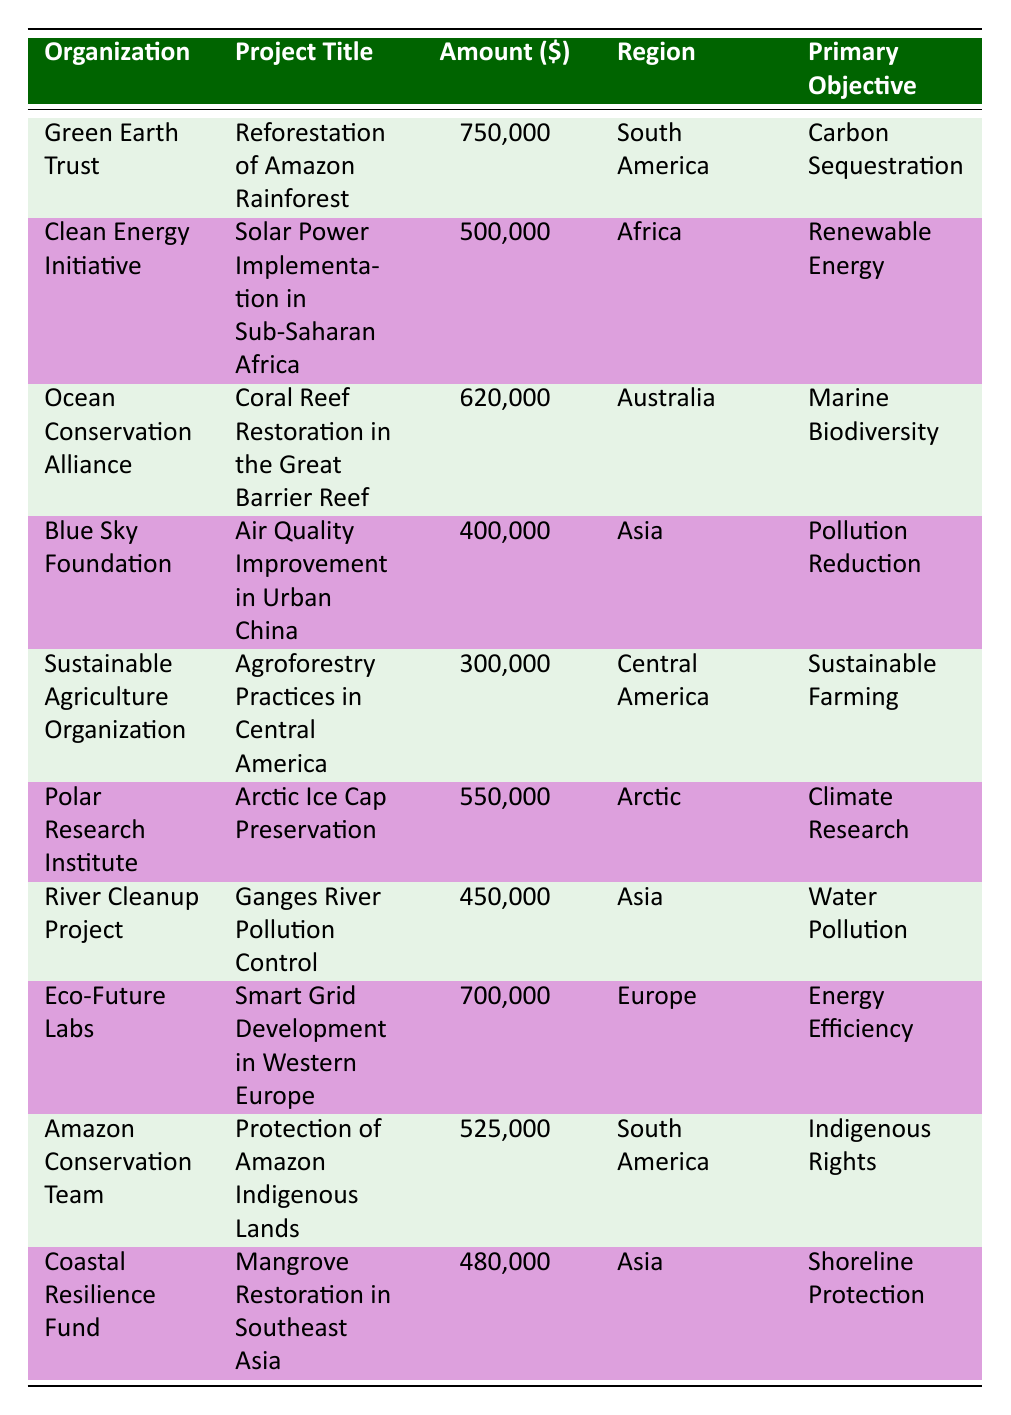How much was allocated to the project "Air Quality Improvement in Urban China"? The table lists "Air Quality Improvement in Urban China" under the organization "Blue Sky Foundation" with an allocated amount of 400,000.
Answer: 400000 What is the primary objective of the "Solar Power Implementation in Sub-Saharan Africa" project? The primary objective for the project titled "Solar Power Implementation in Sub-Saharan Africa" is listed as "Renewable Energy" in the table.
Answer: Renewable Energy Which region received the most funding for climate initiatives? The table shows that South America has two projects with funding amounts of 750,000 and 525,000. The highest amount is 750,000 for the "Reforestation of Amazon Rainforest" project. Africa received 500,000, Australia 620,000, and others received less. Thus, the highest funding goes to South America with 750,000.
Answer: South America What is the total amount allocated to projects in Asia? To find the total amount allocated to Asia, we sum the amounts for projects in that region: 400,000 (Blue Sky Foundation) + 450,000 (River Cleanup Project) + 480,000 (Coastal Resilience Fund) = 1,330,000.
Answer: 1330000 Is it true that "Protection of Amazon Indigenous Lands" has a higher funding amount than the "Smart Grid Development in Western Europe"? The "Protection of Amazon Indigenous Lands" project has an allocated amount of 525,000, while "Smart Grid Development in Western Europe" has 700,000. Since 525,000 is less than 700,000, the statement is false.
Answer: No Which organization focuses on marine biodiversity and how much funding did it receive? The organization "Ocean Conservation Alliance" focuses on marine biodiversity through the project "Coral Reef Restoration in the Great Barrier Reef" and was allocated 620,000 as per the table.
Answer: Ocean Conservation Alliance, 620000 What percentage of the total funding is allocated to the project "Arctic Ice Cap Preservation"? First, we calculate the total funding: 750,000 + 500,000 + 620,000 + 400,000 + 300,000 + 550,000 + 450,000 + 700,000 + 525,000 + 480,000 = 5,775,000. The amount allocated to "Arctic Ice Cap Preservation" is 550,000. The percentage can be calculated as (550,000 / 5,775,000) * 100 = 9.52%.
Answer: 9.52 How many projects were approved in North America? The table does not list any projects approved in North America. All listed projects are from South America, Africa, Australia, Asia, Central America, the Arctic, and Europe.
Answer: 0 Which project aimed to address water pollution and what was its funding amount? The project "Ganges River Pollution Control" aimed to address water pollution and received 450,000 according to the table.
Answer: Ganges River Pollution Control, 450000 